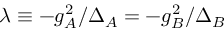Convert formula to latex. <formula><loc_0><loc_0><loc_500><loc_500>\lambda \equiv - g _ { A } ^ { 2 } / { \Delta _ { A } } = - g _ { B } ^ { 2 } / { \Delta _ { B } }</formula> 